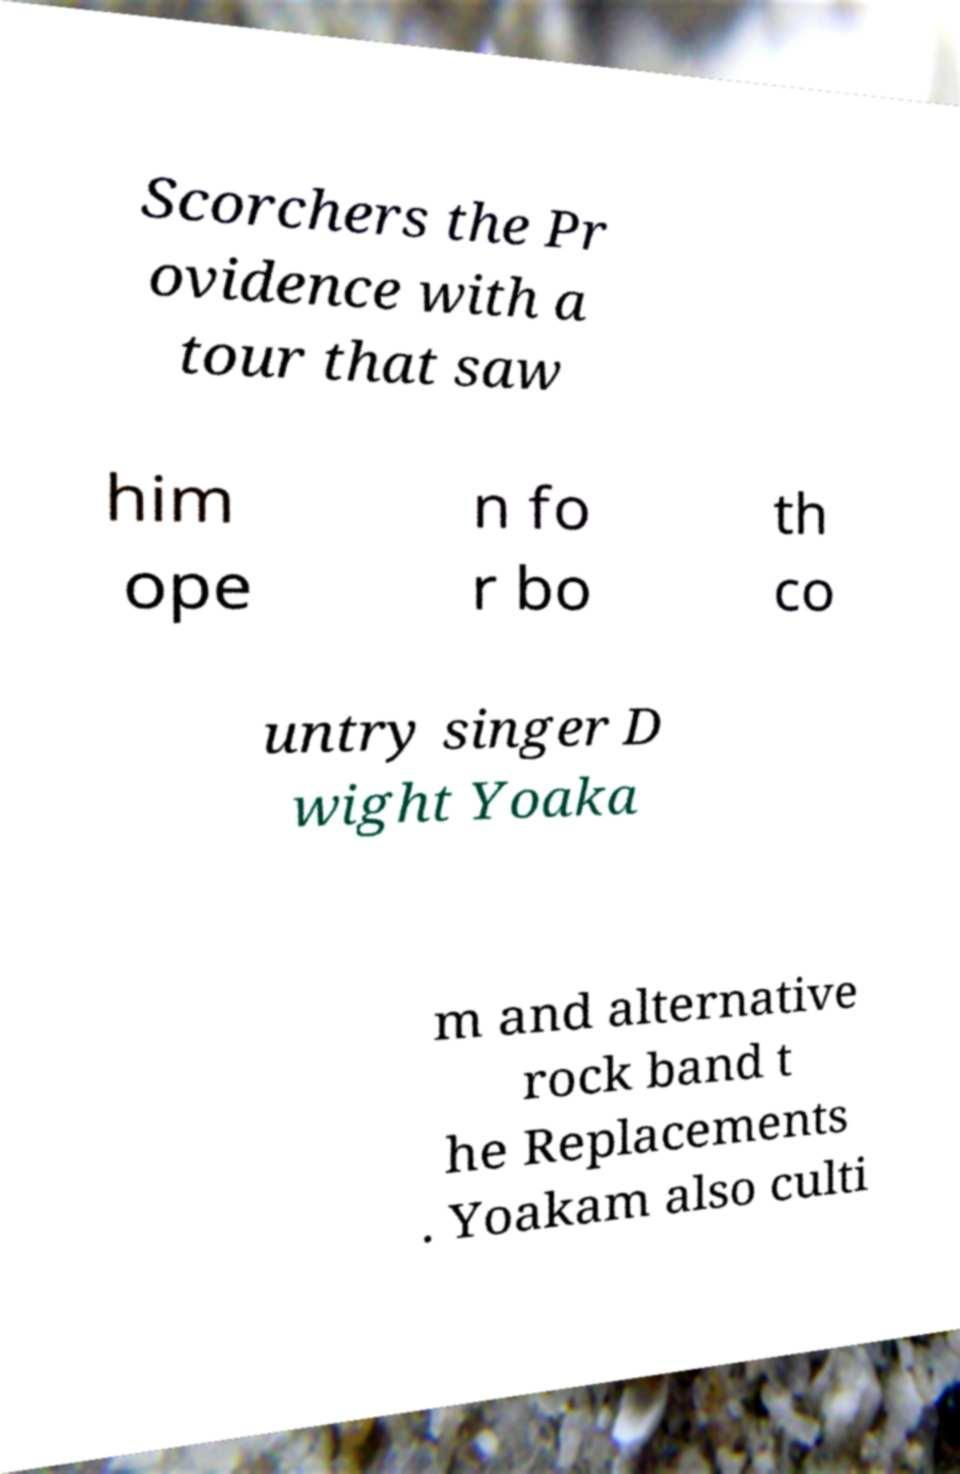What messages or text are displayed in this image? I need them in a readable, typed format. Scorchers the Pr ovidence with a tour that saw him ope n fo r bo th co untry singer D wight Yoaka m and alternative rock band t he Replacements . Yoakam also culti 